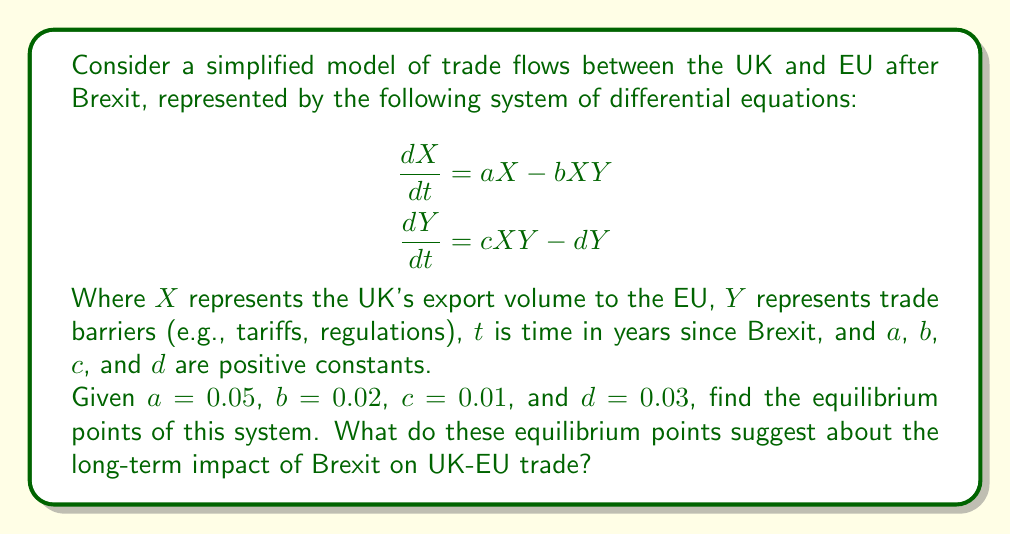Help me with this question. To find the equilibrium points, we need to set both equations equal to zero and solve for $X$ and $Y$:

1) Set $\frac{dX}{dt} = 0$ and $\frac{dY}{dt} = 0$:

   $$\begin{aligned}
   0 &= aX - bXY \\
   0 &= cXY - dY
   \end{aligned}$$

2) From the second equation:
   
   $cXY = dY$
   $Y(cX - d) = 0$

   This gives us two possibilities: $Y = 0$ or $cX - d = 0$

3) Case 1: If $Y = 0$, then from the first equation:
   
   $aX = 0$
   $X = 0$

   This gives us the first equilibrium point: $(X, Y) = (0, 0)$

4) Case 2: If $cX - d = 0$, then:
   
   $X = \frac{d}{c} = \frac{0.03}{0.01} = 3$

   Substituting this into the first equation:

   $0 = aX - bXY$
   $0 = 0.05(3) - 0.02(3)Y$
   $0.15 = 0.06Y$
   $Y = \frac{0.15}{0.06} = 2.5$

   This gives us the second equilibrium point: $(X, Y) = (3, 2.5)$

5) Interpretation:
   - The $(0, 0)$ equilibrium represents a scenario where trade completely ceases.
   - The $(3, 2.5)$ equilibrium represents a new steady state where trade continues but at a reduced level compared to pre-Brexit conditions, with some trade barriers in place.

These equilibrium points suggest that in the long term, Brexit could lead to either a dramatic reduction in trade (though complete cessation is unlikely in reality) or a new equilibrium with reduced trade and increased barriers compared to the pre-Brexit situation.
Answer: The equilibrium points are $(0, 0)$ and $(3, 2.5)$. These suggest that Brexit could lead to either a severe reduction in UK-EU trade or a new equilibrium with reduced trade and increased barriers. 